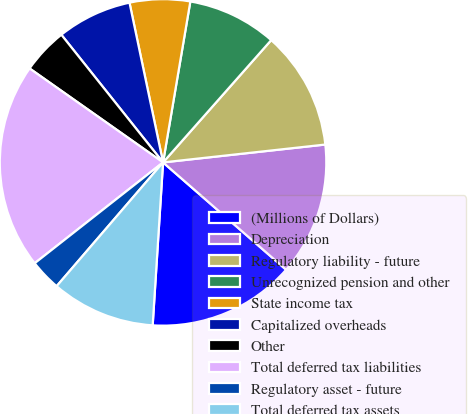Convert chart to OTSL. <chart><loc_0><loc_0><loc_500><loc_500><pie_chart><fcel>(Millions of Dollars)<fcel>Depreciation<fcel>Regulatory liability - future<fcel>Unrecognized pension and other<fcel>State income tax<fcel>Capitalized overheads<fcel>Other<fcel>Total deferred tax liabilities<fcel>Regulatory asset - future<fcel>Total deferred tax assets<nl><fcel>14.6%<fcel>13.16%<fcel>11.73%<fcel>8.85%<fcel>5.97%<fcel>7.41%<fcel>4.53%<fcel>20.36%<fcel>3.1%<fcel>10.29%<nl></chart> 